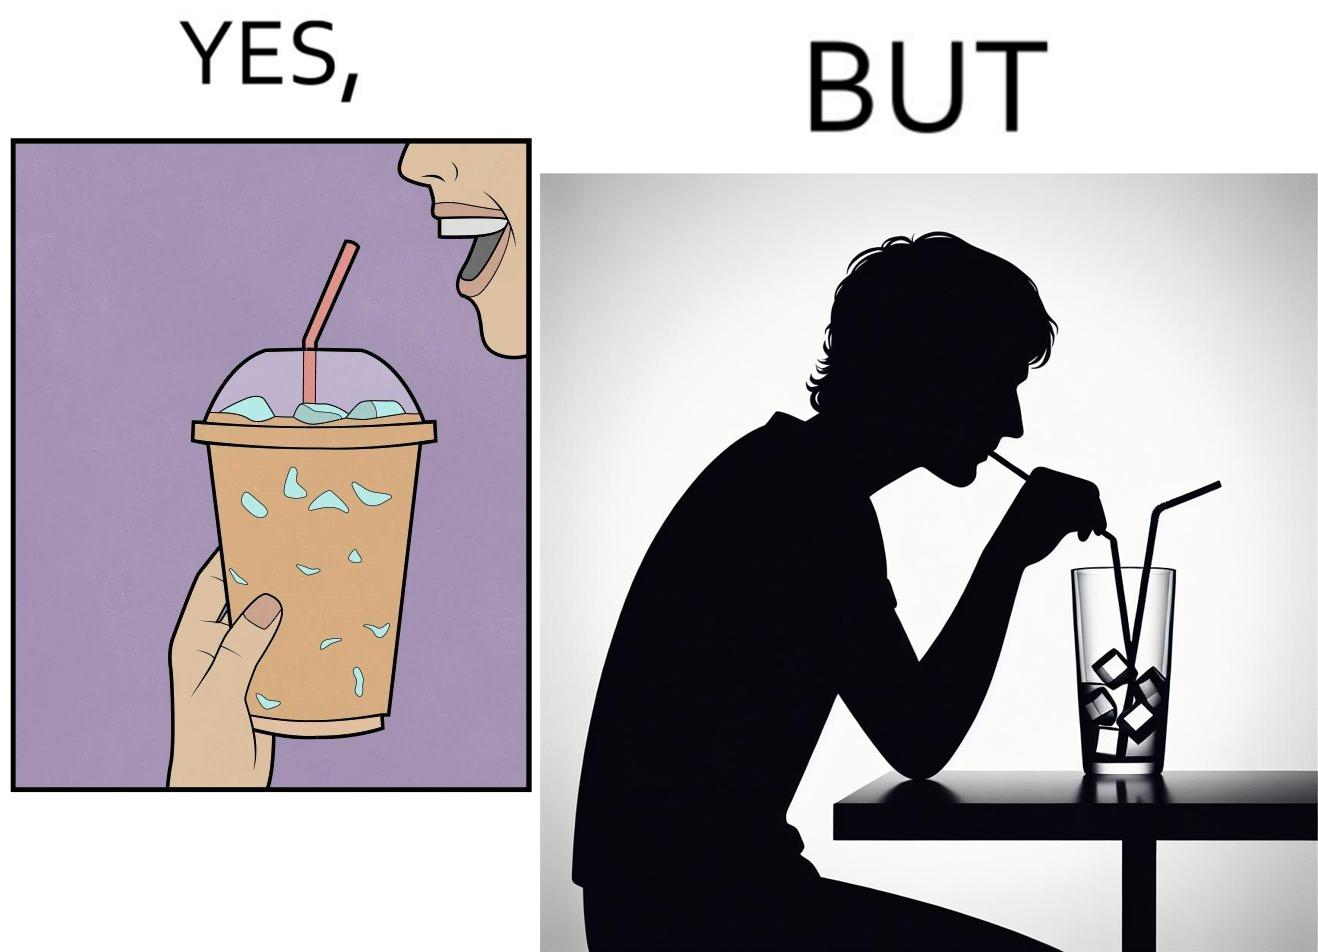Describe what you see in this image. The image is funny, as the drink seems to be full to begin with, while most of the volume of the drink is occupied by the ice cubes. 